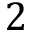Convert formula to latex. <formula><loc_0><loc_0><loc_500><loc_500>2</formula> 